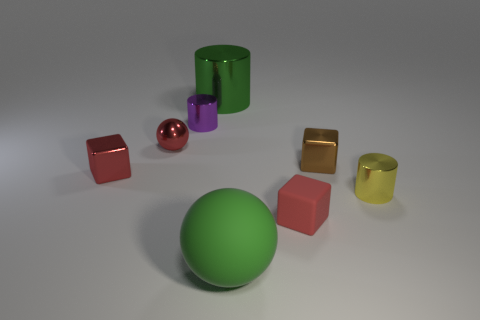Subtract all tiny metal blocks. How many blocks are left? 1 Subtract all green cylinders. How many red cubes are left? 2 Add 2 tiny yellow rubber cylinders. How many objects exist? 10 Subtract all green spheres. How many spheres are left? 1 Subtract all balls. How many objects are left? 6 Subtract 1 cubes. How many cubes are left? 2 Subtract all gray blocks. Subtract all green cylinders. How many blocks are left? 3 Subtract all blue matte cylinders. Subtract all large green rubber things. How many objects are left? 7 Add 2 rubber balls. How many rubber balls are left? 3 Add 6 big brown rubber cylinders. How many big brown rubber cylinders exist? 6 